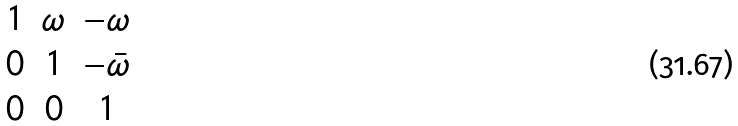<formula> <loc_0><loc_0><loc_500><loc_500>\begin{matrix} 1 & \omega & - \omega \\ 0 & 1 & - \bar { \omega } \\ 0 & 0 & 1 \end{matrix}</formula> 